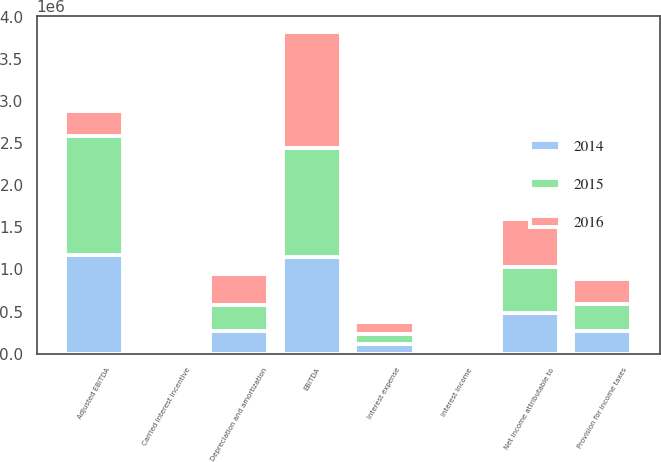Convert chart to OTSL. <chart><loc_0><loc_0><loc_500><loc_500><stacked_bar_chart><ecel><fcel>Net income attributable to<fcel>Depreciation and amortization<fcel>Interest expense<fcel>Provision for income taxes<fcel>Interest income<fcel>EBITDA<fcel>Carried interest incentive<fcel>Adjusted EBITDA<nl><fcel>2016<fcel>571973<fcel>366927<fcel>144851<fcel>296662<fcel>8051<fcel>1.37236e+06<fcel>15558<fcel>296662<nl><fcel>2015<fcel>547132<fcel>314096<fcel>118880<fcel>320853<fcel>6311<fcel>1.29734e+06<fcel>26085<fcel>1.41272e+06<nl><fcel>2014<fcel>484503<fcel>265101<fcel>112035<fcel>263759<fcel>6233<fcel>1.14225e+06<fcel>23873<fcel>1.16612e+06<nl></chart> 